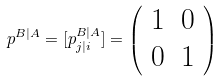Convert formula to latex. <formula><loc_0><loc_0><loc_500><loc_500>p ^ { B | A } = [ p ^ { B | A } _ { j | i } ] = \left ( \begin{array} { c c } 1 & 0 \\ 0 & 1 \end{array} \right )</formula> 